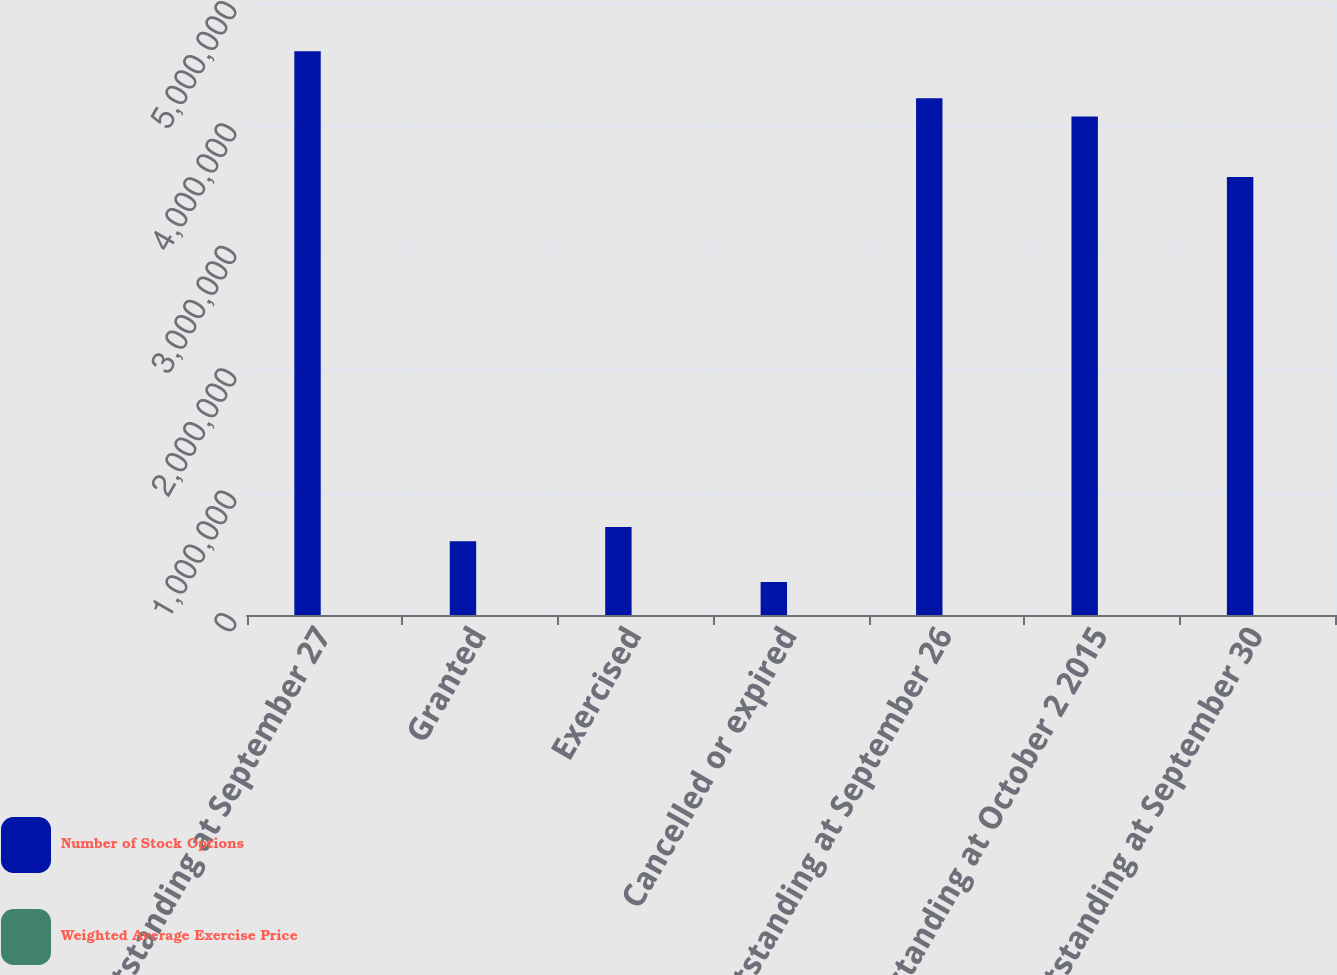Convert chart to OTSL. <chart><loc_0><loc_0><loc_500><loc_500><stacked_bar_chart><ecel><fcel>Outstanding at September 27<fcel>Granted<fcel>Exercised<fcel>Cancelled or expired<fcel>Outstanding at September 26<fcel>Outstanding at October 2 2015<fcel>Outstanding at September 30<nl><fcel>Number of Stock Options<fcel>4.60621e+06<fcel>602525<fcel>718065<fcel>269525<fcel>4.22115e+06<fcel>4.07271e+06<fcel>3.57751e+06<nl><fcel>Weighted Average Exercise Price<fcel>52.33<fcel>53.51<fcel>47.18<fcel>54.46<fcel>53.23<fcel>46.06<fcel>45.69<nl></chart> 